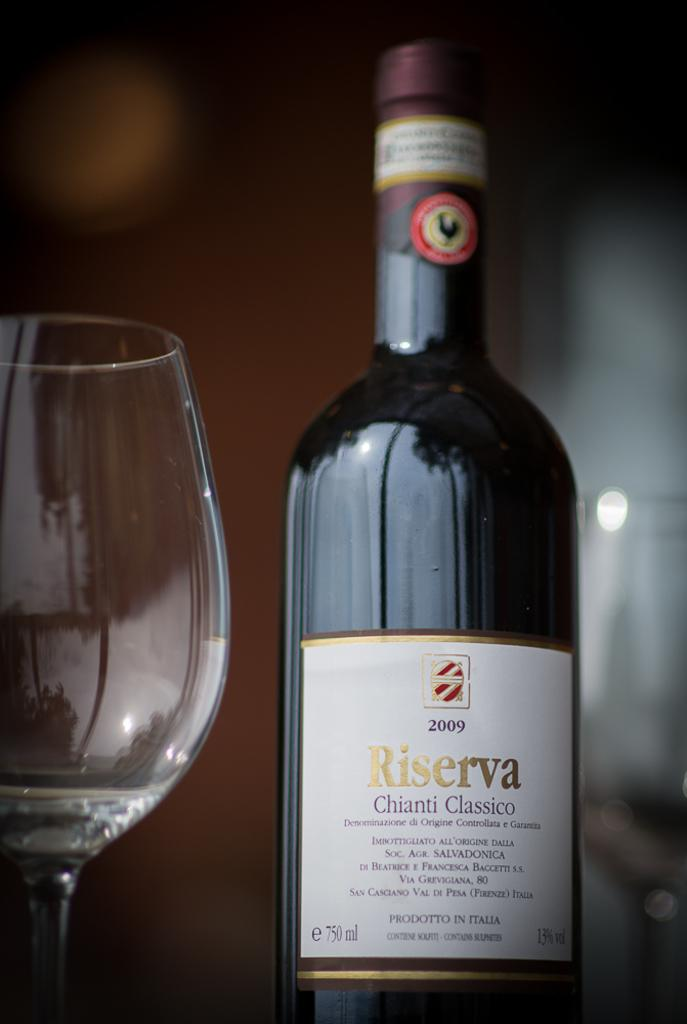<image>
Render a clear and concise summary of the photo. "Riserva" is on the label of a bottle. 